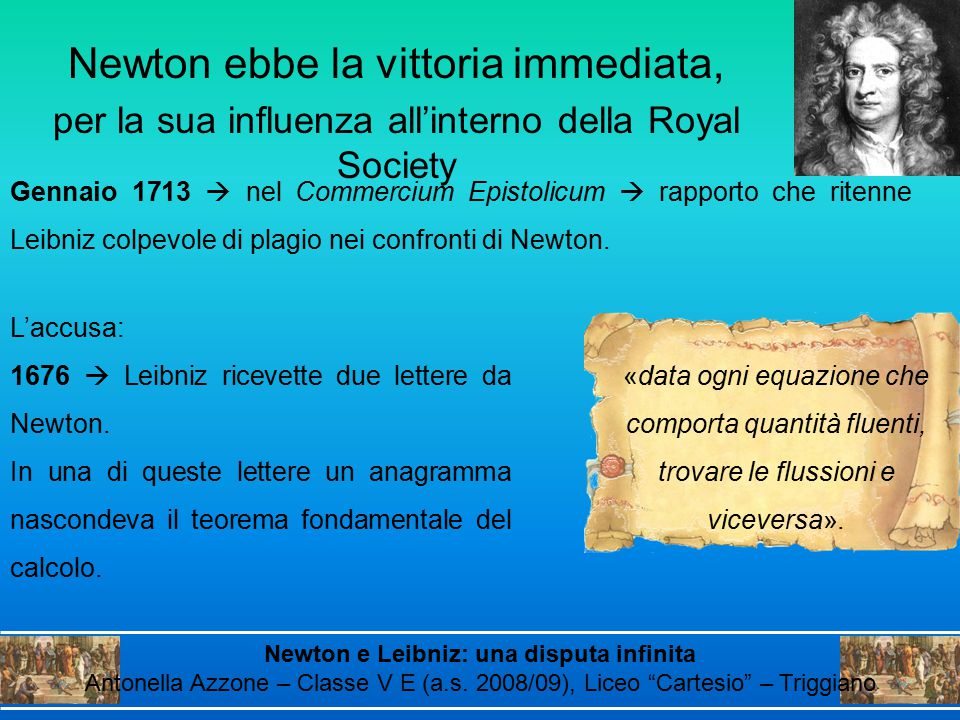Imagine Newton's anagram was hidden in a modern scientific paper. How might the discovery process change compared to the 17th century? If Newton's anagram were hidden in a modern scientific paper, the discovery process would be vastly different, leveraging contemporary tools and communication channels. Today, cryptographic methods and digital archives would facilitate the encoding and decoding of such anagrammatic messages. Unlike the 17th century, where letters and physical documents were primary modes of communication, modern scientists use encrypted files, emails, and online journals to share their findings securely. The scrutiny of priority claims would involve a larger, more connected global community of researchers, peer reviewers, and digital timestamping methods, ensuring transparency and authenticity. Advanced software tools could quickly analyze and decipher anagrams, speeding up the resolution of any intellectual property disputes. Thus, the evolution of technology and communication fundamentally alters the dynamics of discovery and prioritizes a more systematic and accessible approach to scientific claims. What fictional event could happen if Newton and Leibniz were to suddenly appear in today's world? If Newton and Leibniz were to suddenly appear in today's world, it could lead to an extraordinary scientific renaissance. Imagine an international symposium where these two pioneers are the keynote speakers. They'd be bewildered yet fascinated by modern advancements in mathematics, physics, and technology. Equipped with our current understanding and tools, they'd collaborate on groundbreaking research, potentially revolutionizing quantum computing or developing new theories in cosmology. The event would be a media sensation, with live-streamed debates and discussions captivating audiences worldwide. A Netflix documentary series titled 'Calculus Reborn' would follow their journey, exploring their reactions to modern discoveries and their contributions to contemporary science. Their presence would not only bridge historical gaps but also inspire a new generation of scientists, blending classical wisdom with modern innovation. 